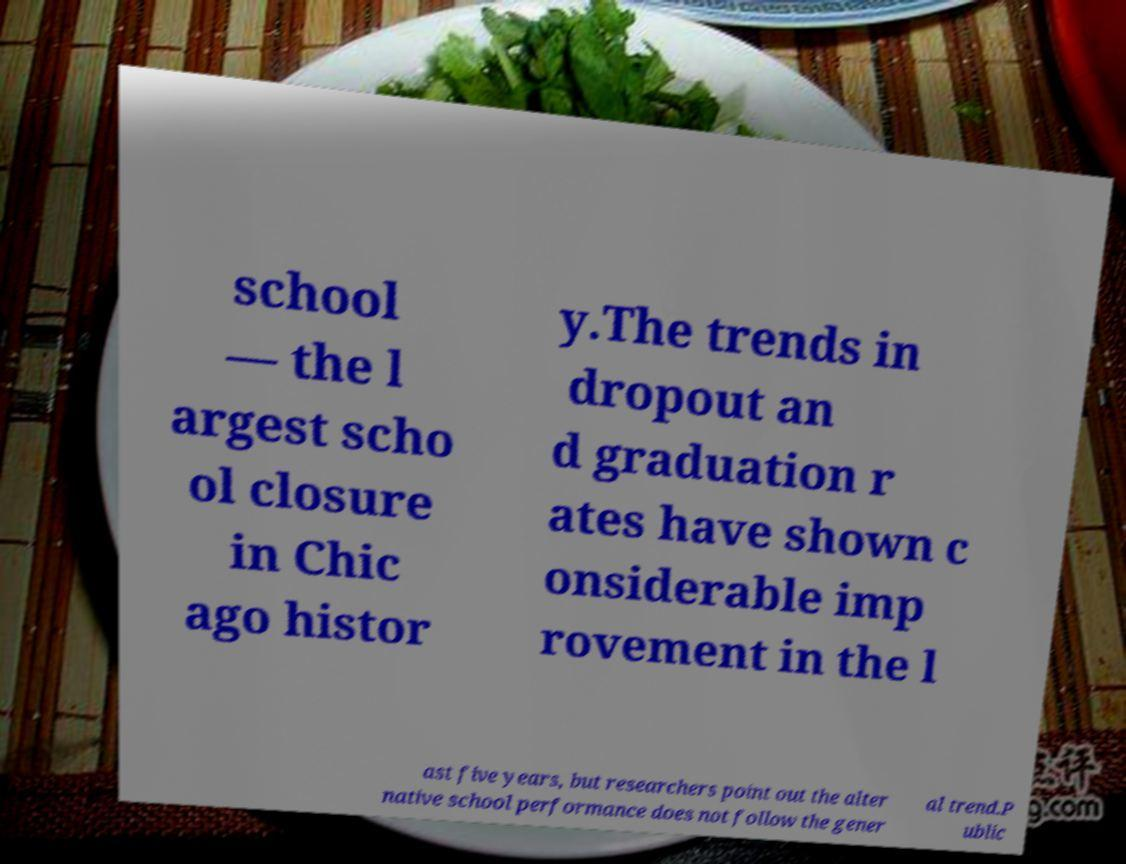For documentation purposes, I need the text within this image transcribed. Could you provide that? school — the l argest scho ol closure in Chic ago histor y.The trends in dropout an d graduation r ates have shown c onsiderable imp rovement in the l ast five years, but researchers point out the alter native school performance does not follow the gener al trend.P ublic 